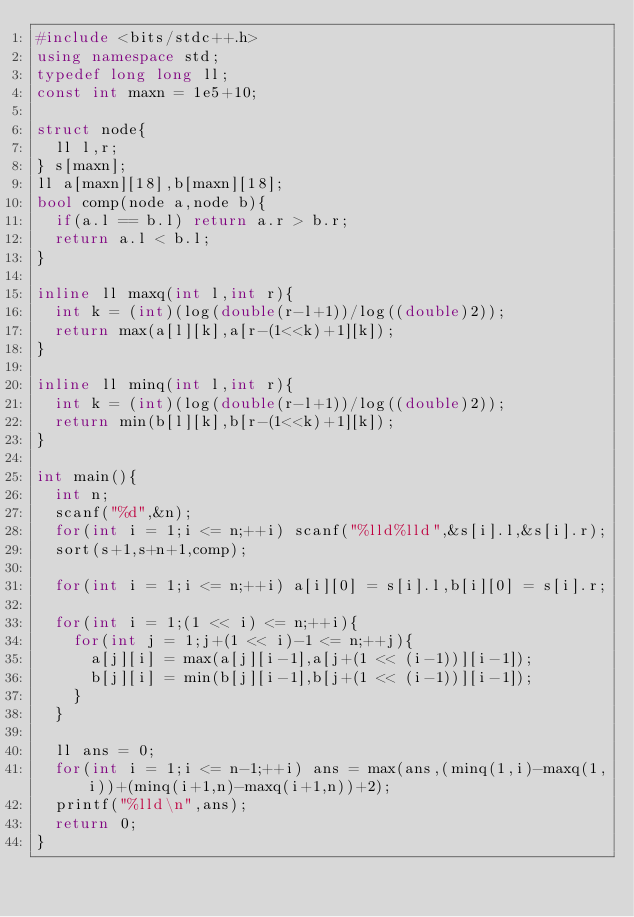Convert code to text. <code><loc_0><loc_0><loc_500><loc_500><_C++_>#include <bits/stdc++.h>
using namespace std;
typedef long long ll;
const int maxn = 1e5+10;

struct node{
	ll l,r;
} s[maxn];
ll a[maxn][18],b[maxn][18];
bool comp(node a,node b){
	if(a.l == b.l) return a.r > b.r;
	return a.l < b.l;
}

inline ll maxq(int l,int r){
	int k = (int)(log(double(r-l+1))/log((double)2));
	return max(a[l][k],a[r-(1<<k)+1][k]);
}

inline ll minq(int l,int r){
	int k = (int)(log(double(r-l+1))/log((double)2));
	return min(b[l][k],b[r-(1<<k)+1][k]);
}

int main(){
	int n;
	scanf("%d",&n);
	for(int i = 1;i <= n;++i) scanf("%lld%lld",&s[i].l,&s[i].r);
	sort(s+1,s+n+1,comp);
	
	for(int i = 1;i <= n;++i) a[i][0] = s[i].l,b[i][0] = s[i].r;
	
	for(int i = 1;(1 << i) <= n;++i){
		for(int j = 1;j+(1 << i)-1 <= n;++j){
			a[j][i] = max(a[j][i-1],a[j+(1 << (i-1))][i-1]);
			b[j][i] = min(b[j][i-1],b[j+(1 << (i-1))][i-1]);
		}
	}
	
	ll ans = 0;
	for(int i = 1;i <= n-1;++i) ans = max(ans,(minq(1,i)-maxq(1,i))+(minq(i+1,n)-maxq(i+1,n))+2);
	printf("%lld\n",ans);
	return 0;
}</code> 